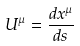Convert formula to latex. <formula><loc_0><loc_0><loc_500><loc_500>U ^ { \mu } = \frac { d x ^ { \mu } } { d s }</formula> 